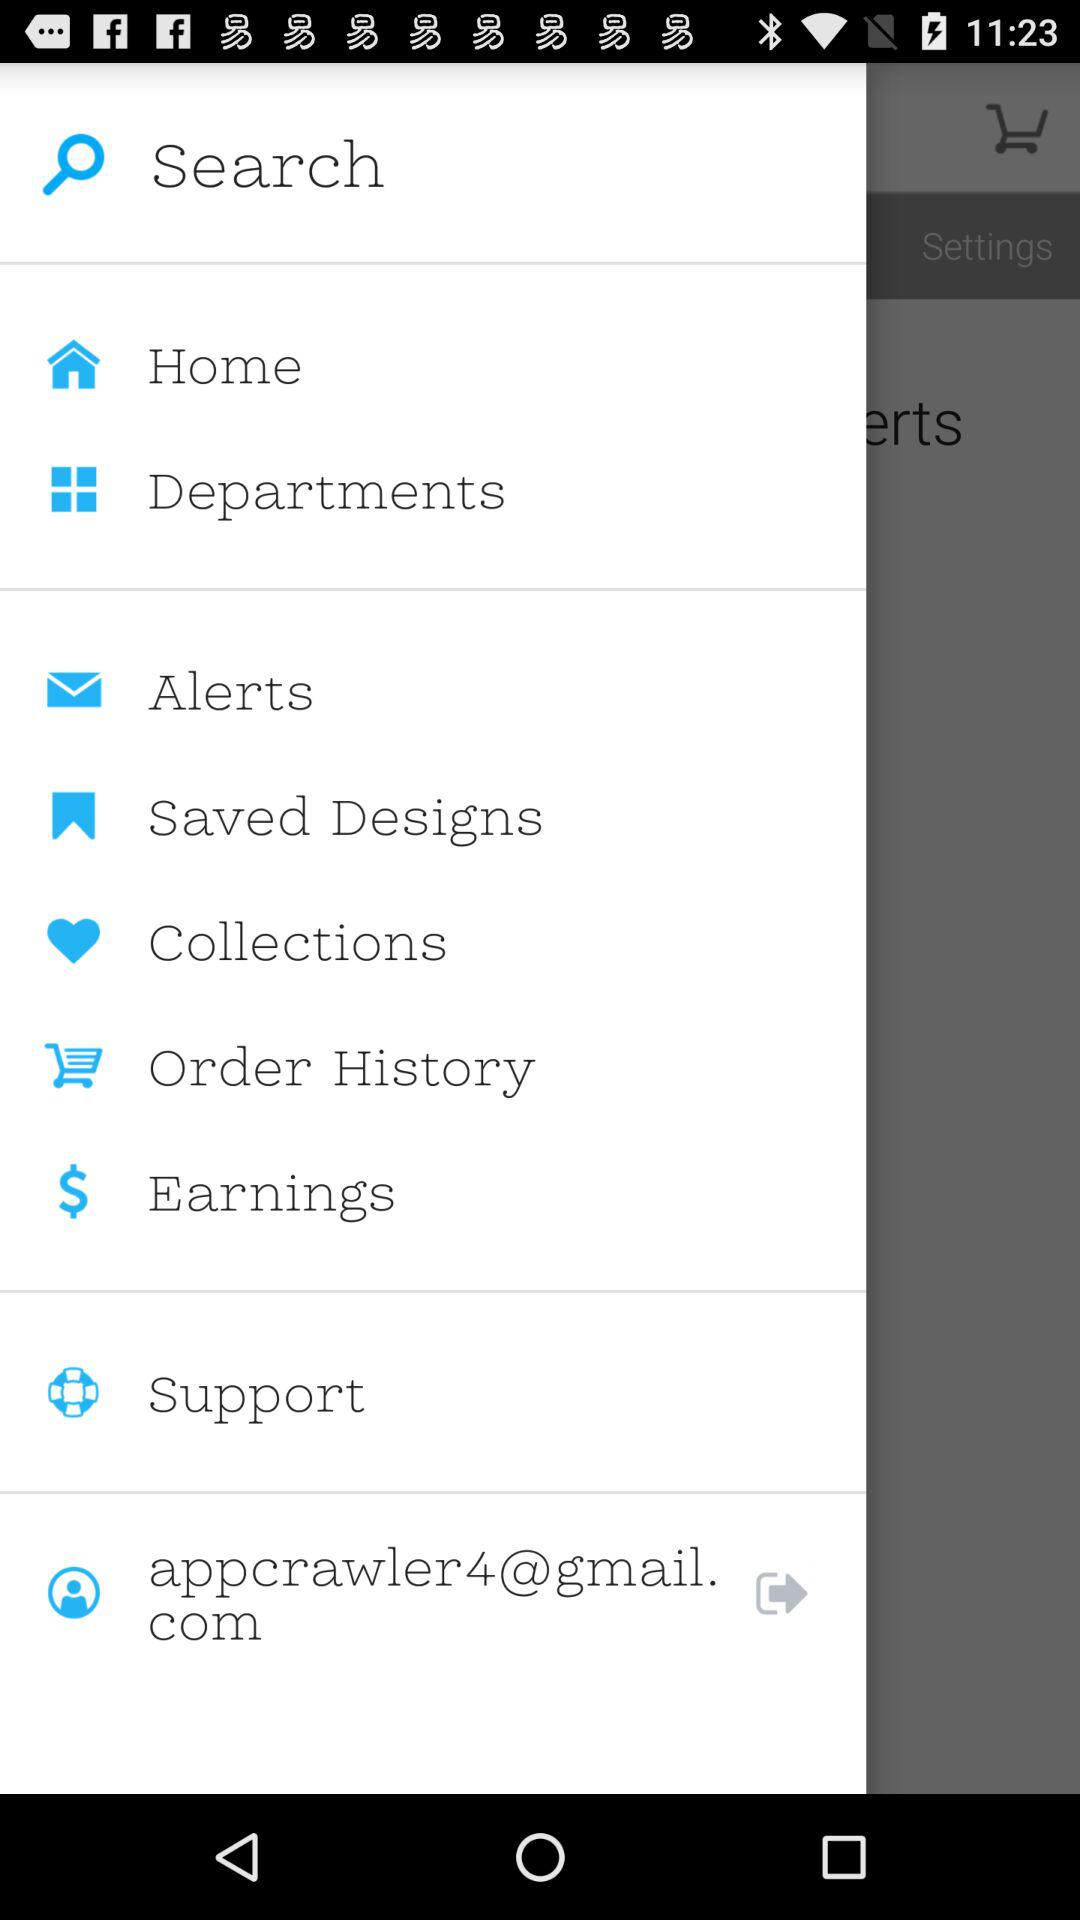What is the email address? The email address is appcrawler4@gmail.com. 